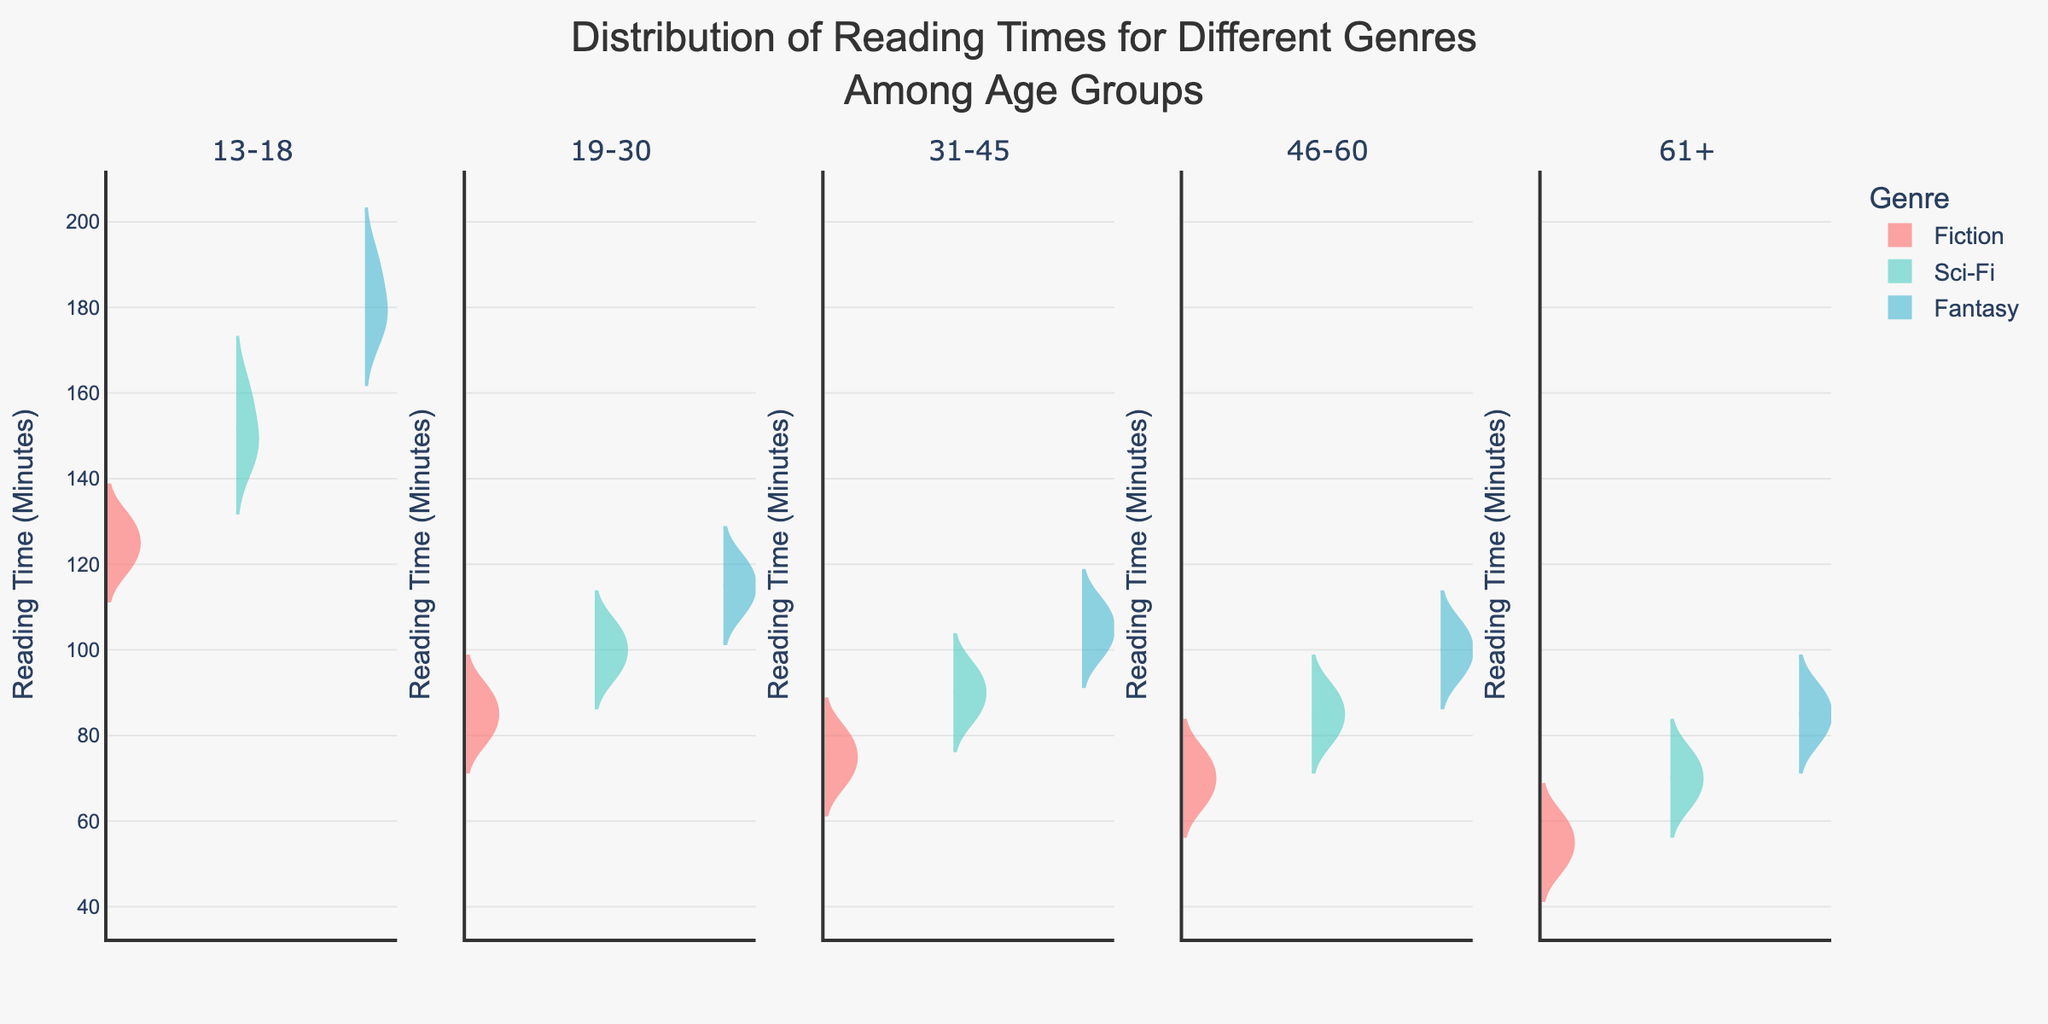How many different age groups are represented in the plot? The subplot titles represent different age groups. We can count the number of these titles to determine the number of different age groups.
Answer: 5 Which genre has the widest distribution of reading times for the 13-18 age group? By observing the width and range of the violin plots for each genre in the subplot for the 13-18 age group, we see that the Fantasy genre has the widest distribution.
Answer: Fantasy What is the median reading time for Fiction in the 31-45 age group? The median is indicated by the white dot in the violin plot for Fiction in the 31-45 age group. By locating this point, we find the median reading time.
Answer: 75 Compare the median reading times for Sci-Fi across all age groups. Which age group has the highest median? Examine the position of the white dots (medians) in the violin plots for Sci-Fi across all subplots. The plot with the highest median position denotes the age group with the highest median reading time.
Answer: 13-18 For the 19-30 age group, which genre shows the lowest variability in reading times? By observing the narrowness and compactness of the violin plots for each genre in the 19-30 age group subplot, we see that the Fiction genre shows the lowest variability in reading times.
Answer: Fiction How does the distribution of reading times for Fantasy change from the 13-18 age group to the 46-60 age group? Compare the shapes and spreads of the violin plots for Fantasy in the subplots for the 13-18 age group and the 46-60 age group. Notice how the distribution becomes narrower and shifts to lower reading times.
Answer: Narrows and shifts to lower times What is the most noticeable trend in reading times for Fiction as age increases? By examining the violin plots for Fiction across all age groups, it's noticeable that the median reading times generally decrease as age increases.
Answer: Decreasing median times In which age group is the maximum reading time for Sci-Fi closest to the median reading time for Fantasy? Identify the maximum points in the Sci-Fi violin plots and compare them with the median points (white dots) in the Fantasy plots across all age groups.
Answer: 19-30 Which genre shows a consistent decrease in median reading times from the 13-18 age group to the 61+ age group across all age groups? Analyze the positions of the white dots (medians) in the violin plots for each genre across all age groups, noticing which consistently trend downward.
Answer: Fiction 